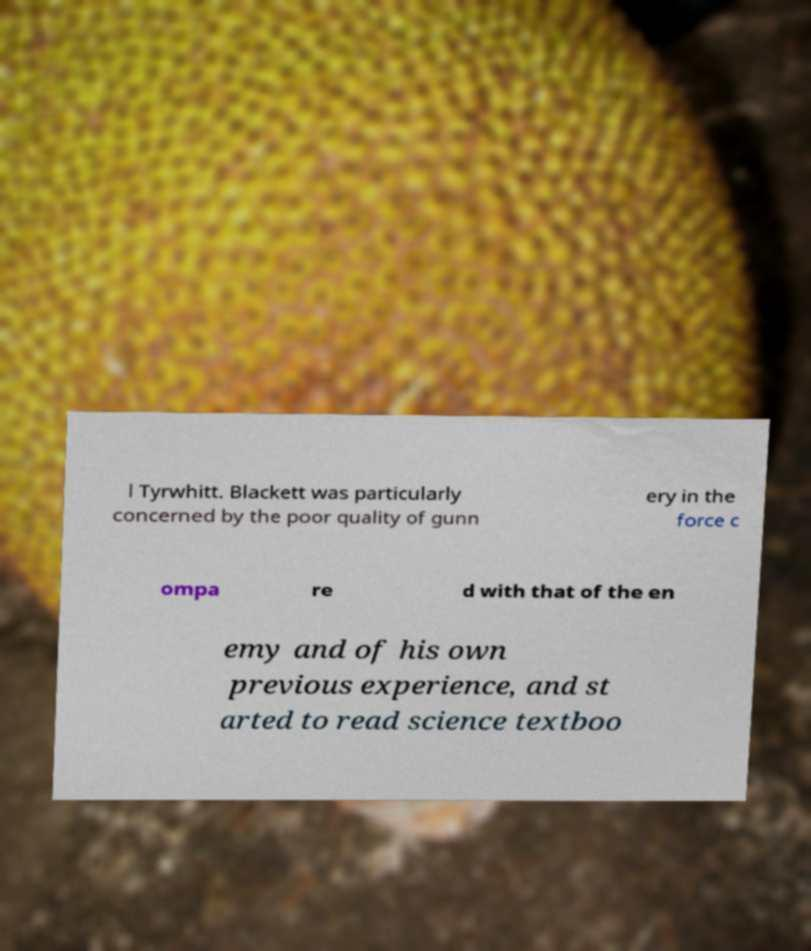Please read and relay the text visible in this image. What does it say? l Tyrwhitt. Blackett was particularly concerned by the poor quality of gunn ery in the force c ompa re d with that of the en emy and of his own previous experience, and st arted to read science textboo 